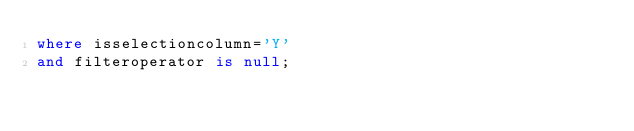<code> <loc_0><loc_0><loc_500><loc_500><_SQL_>where isselectioncolumn='Y'
and filteroperator is null;

</code> 